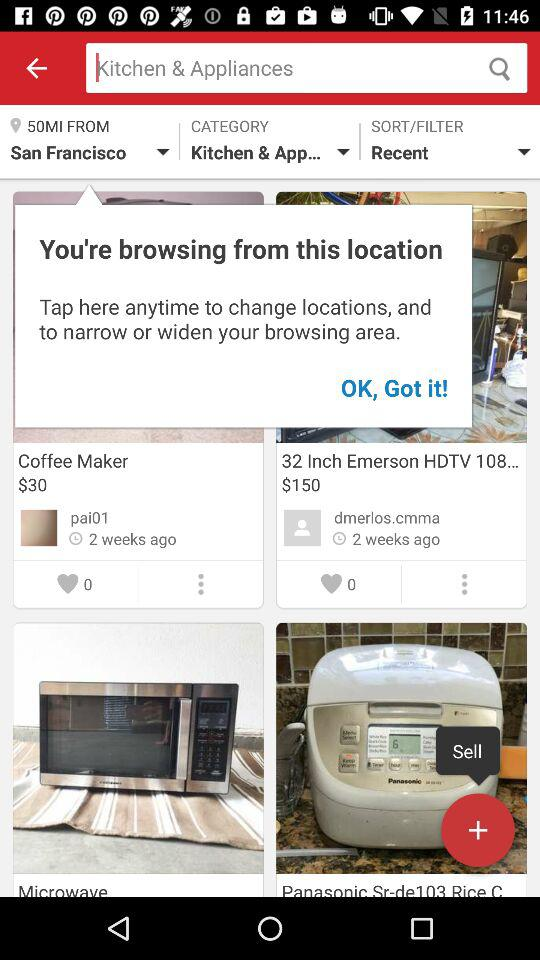What is the price of a coffee maker? The price of a coffee maker is $30. 